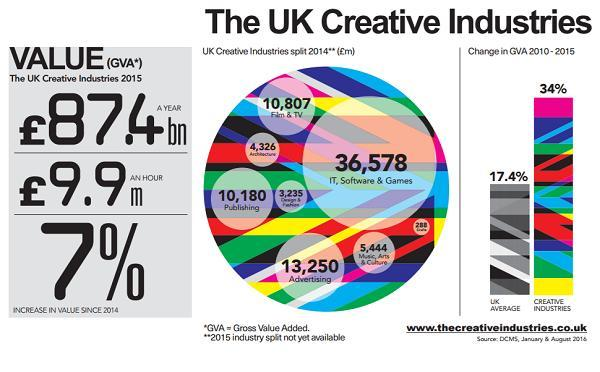What is the difference in GVA percentage between UK average and creative industries during 2010-2015?
Answer the question with a short phrase. 16.6% What is the total GVA of Advertising and Publishing? 23,430 Which Creative Industry in UK had the highest GVA in 2014? IT, Software & Games 